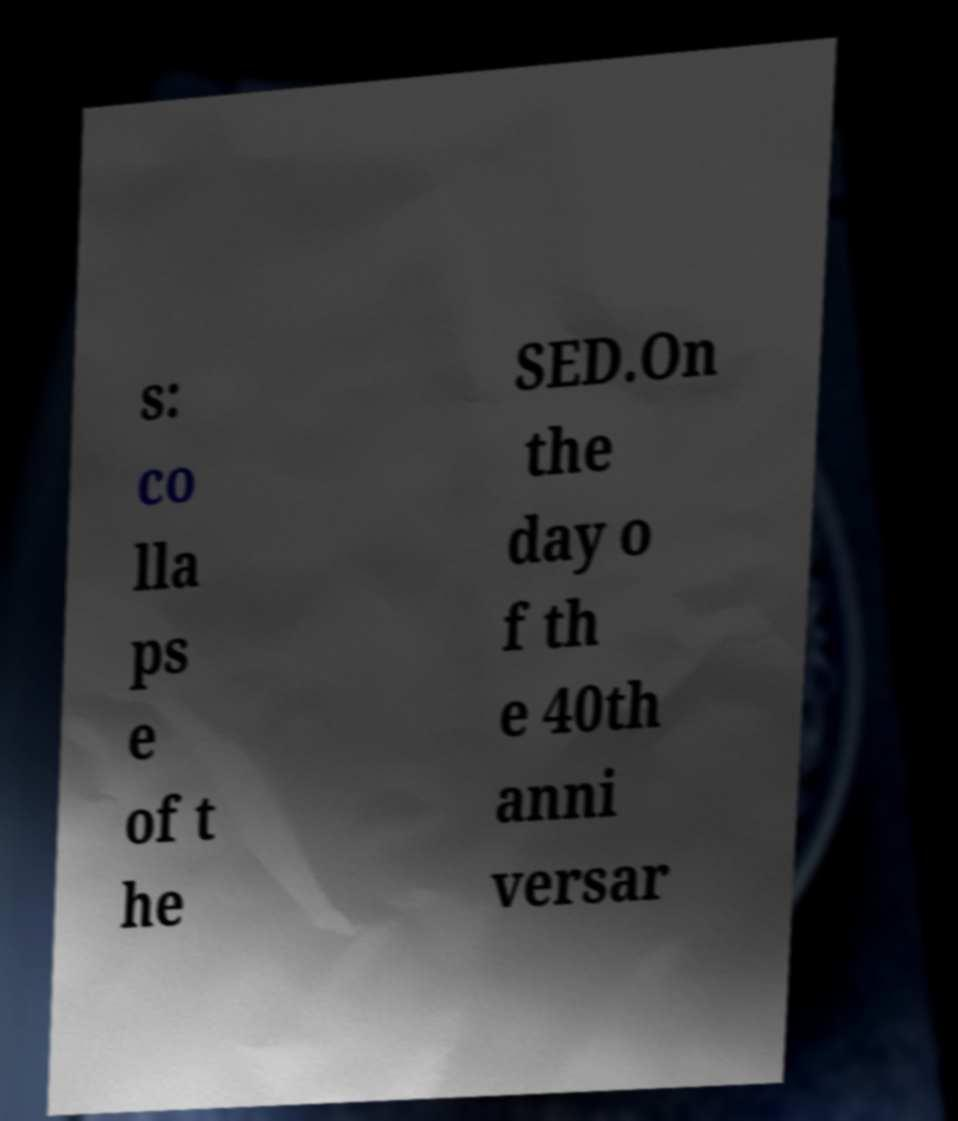I need the written content from this picture converted into text. Can you do that? s: co lla ps e of t he SED.On the day o f th e 40th anni versar 